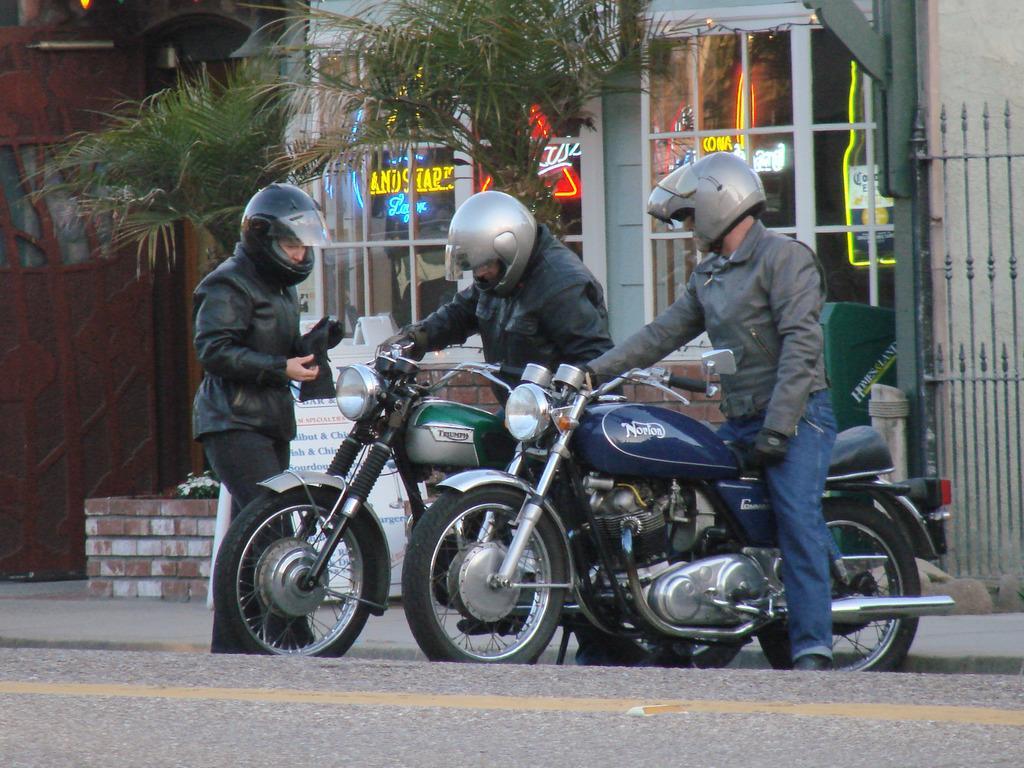Describe this image in one or two sentences. In this picture there are three people, a man who is standing at the left side of the image and two are sitting on the bikes, there are trees at the left side of the image and there is a mall at the right side of the image. 